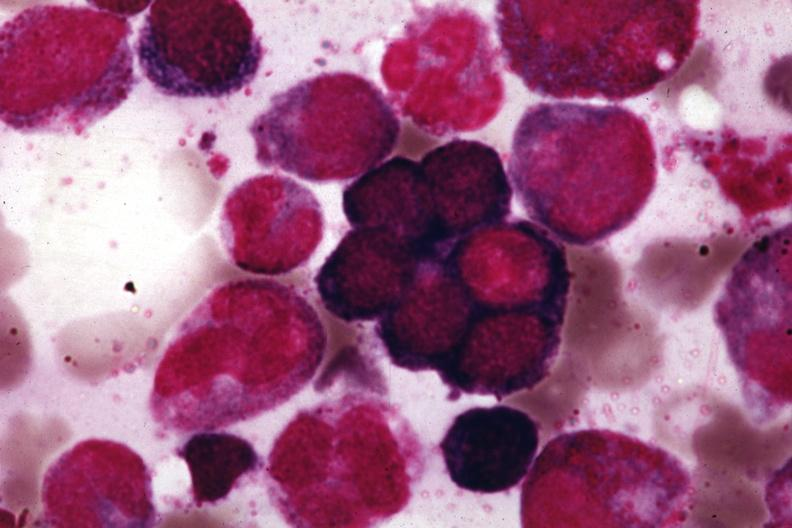s arachnodactyly present?
Answer the question using a single word or phrase. No 